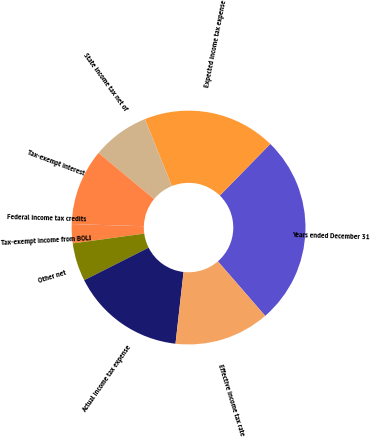<chart> <loc_0><loc_0><loc_500><loc_500><pie_chart><fcel>Years ended December 31<fcel>Expected income tax expense<fcel>State income tax net of<fcel>Tax-exempt interest<fcel>Federal income tax credits<fcel>Tax-exempt income from BOLI<fcel>Other net<fcel>Actual income tax expense<fcel>Effective income tax rate<nl><fcel>26.31%<fcel>18.42%<fcel>7.9%<fcel>10.53%<fcel>0.01%<fcel>2.64%<fcel>5.27%<fcel>15.79%<fcel>13.16%<nl></chart> 